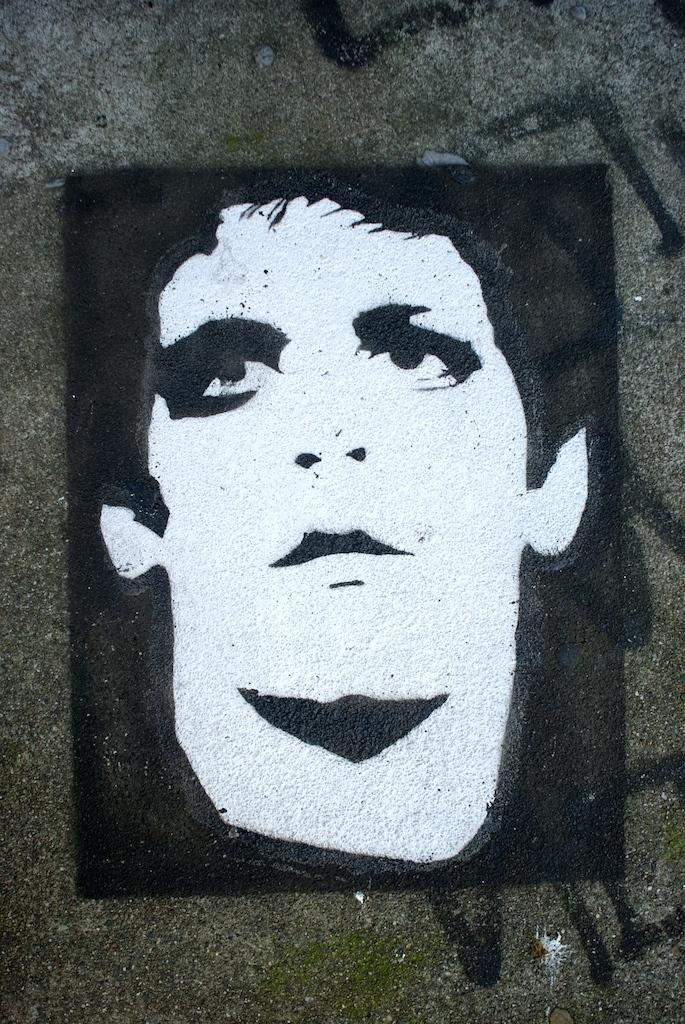What is the main subject of the image? There is a man in the image. What is the man doing in the image? The man is sketching on a wall. How many boys are begging in the alley in the image? There is no alley, beggar, or boys present in the image; it only features a man sketching on a wall. 